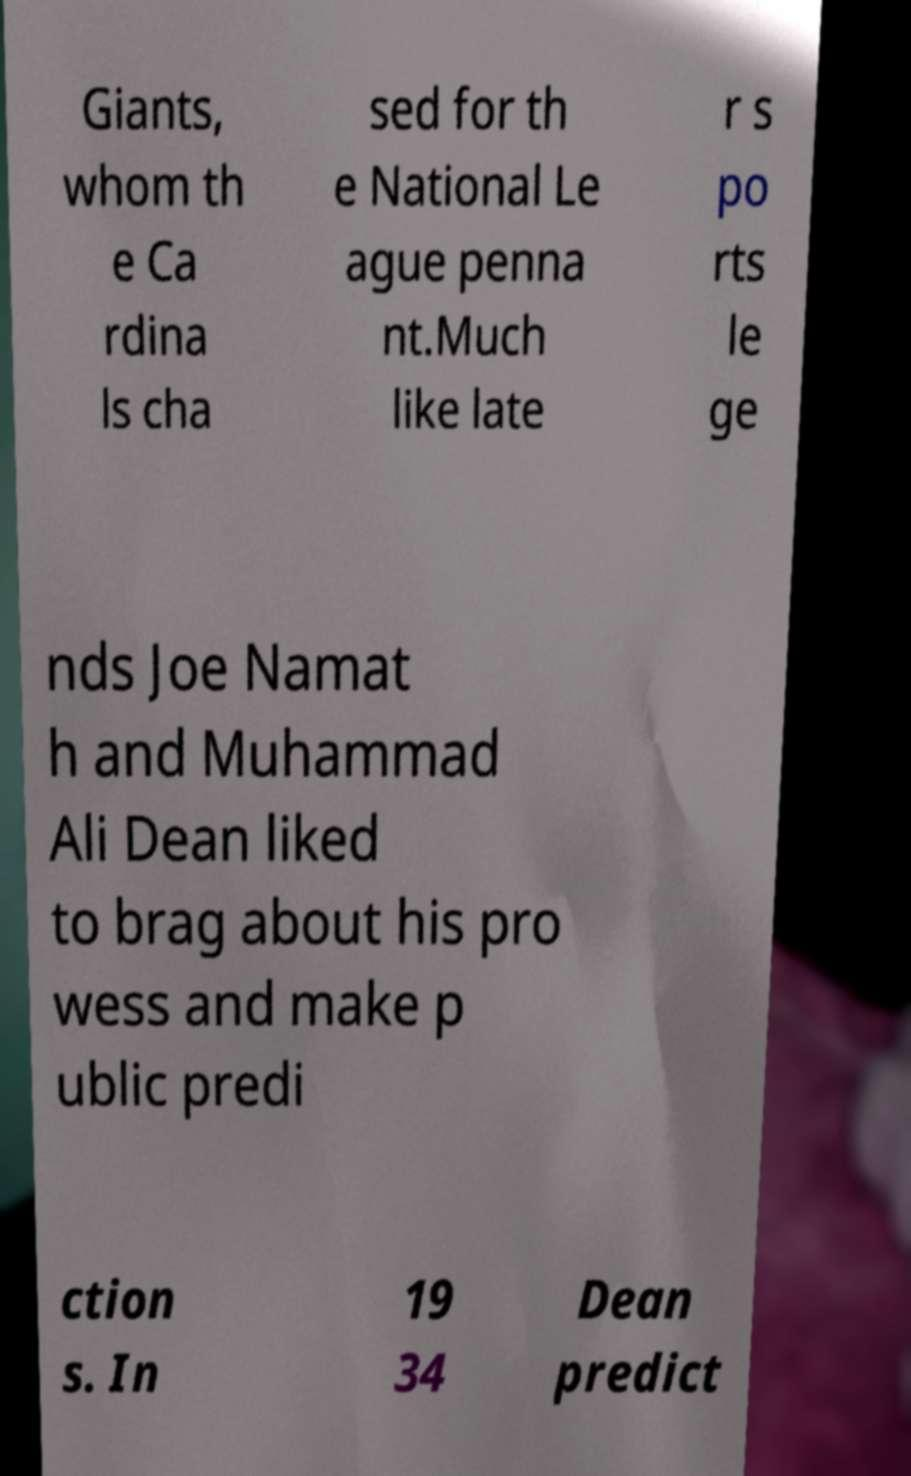Could you extract and type out the text from this image? Giants, whom th e Ca rdina ls cha sed for th e National Le ague penna nt.Much like late r s po rts le ge nds Joe Namat h and Muhammad Ali Dean liked to brag about his pro wess and make p ublic predi ction s. In 19 34 Dean predict 